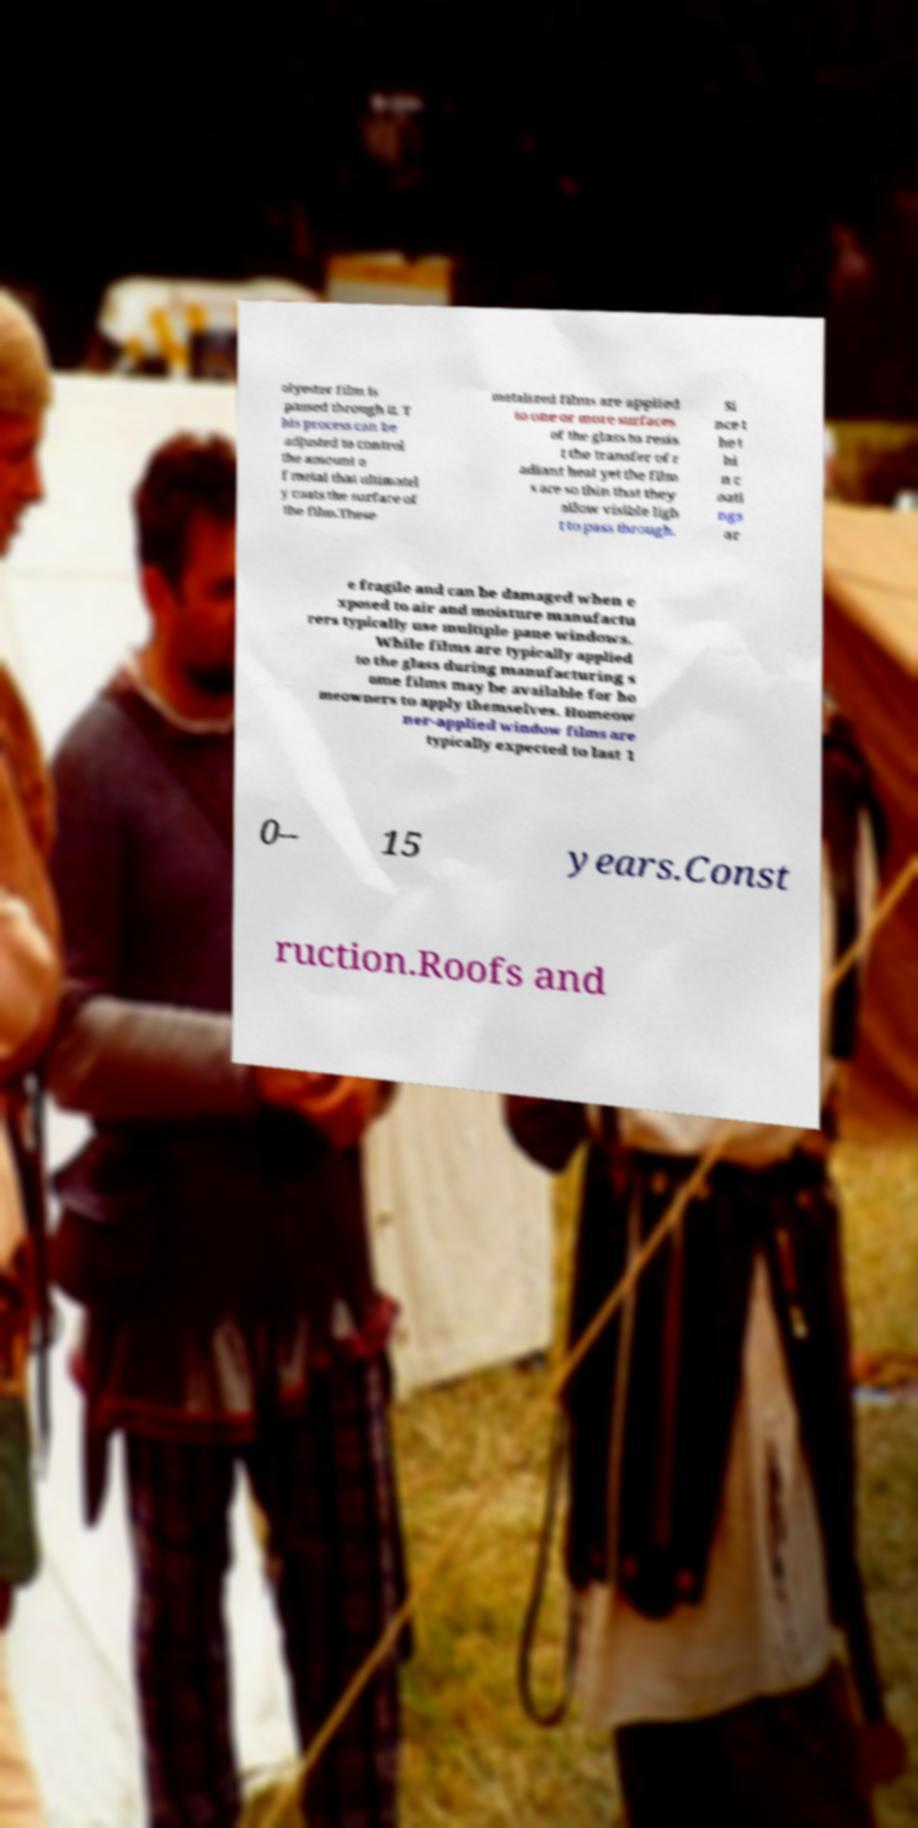For documentation purposes, I need the text within this image transcribed. Could you provide that? olyester film is passed through it. T his process can be adjusted to control the amount o f metal that ultimatel y coats the surface of the film.These metalized films are applied to one or more surfaces of the glass to resis t the transfer of r adiant heat yet the film s are so thin that they allow visible ligh t to pass through. Si nce t he t hi n c oati ngs ar e fragile and can be damaged when e xposed to air and moisture manufactu rers typically use multiple pane windows. While films are typically applied to the glass during manufacturing s ome films may be available for ho meowners to apply themselves. Homeow ner-applied window films are typically expected to last 1 0– 15 years.Const ruction.Roofs and 